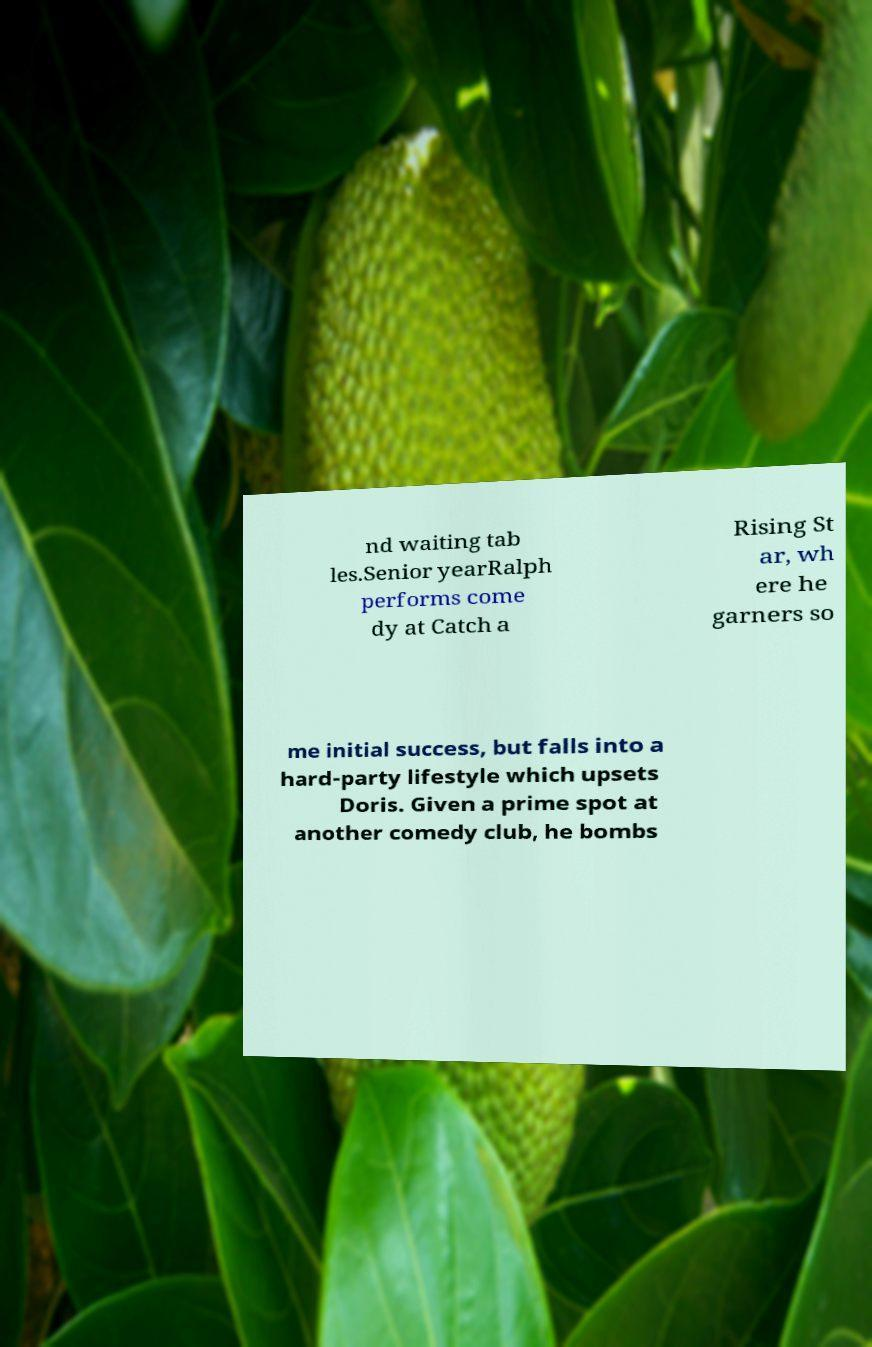For documentation purposes, I need the text within this image transcribed. Could you provide that? nd waiting tab les.Senior yearRalph performs come dy at Catch a Rising St ar, wh ere he garners so me initial success, but falls into a hard-party lifestyle which upsets Doris. Given a prime spot at another comedy club, he bombs 